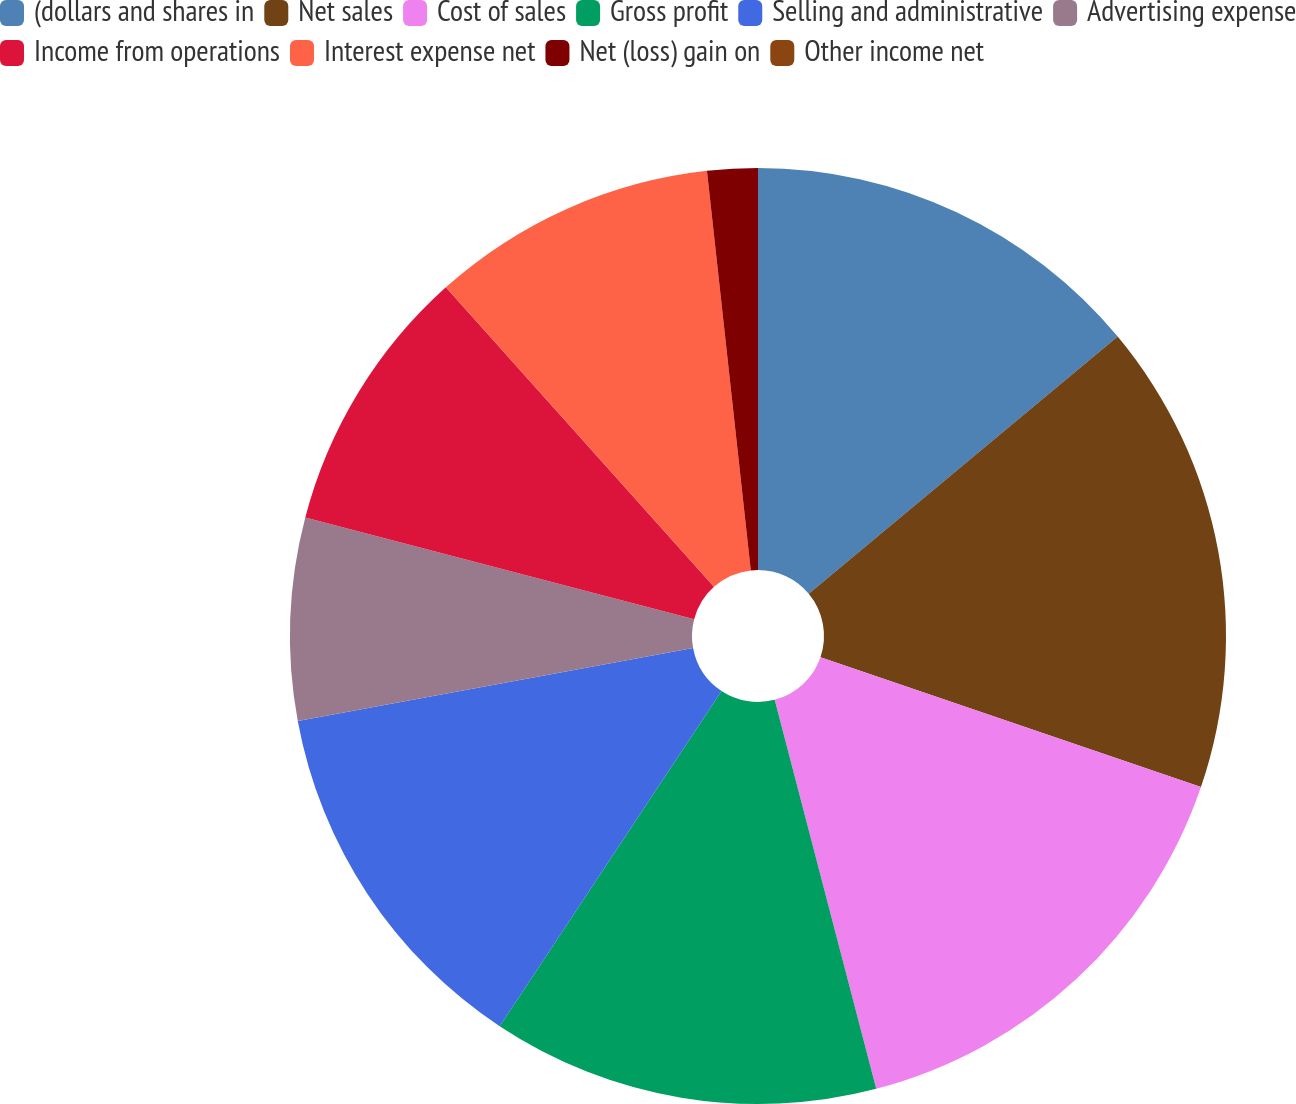<chart> <loc_0><loc_0><loc_500><loc_500><pie_chart><fcel>(dollars and shares in<fcel>Net sales<fcel>Cost of sales<fcel>Gross profit<fcel>Selling and administrative<fcel>Advertising expense<fcel>Income from operations<fcel>Interest expense net<fcel>Net (loss) gain on<fcel>Other income net<nl><fcel>13.95%<fcel>16.28%<fcel>15.7%<fcel>13.37%<fcel>12.79%<fcel>6.98%<fcel>9.3%<fcel>9.88%<fcel>1.74%<fcel>0.0%<nl></chart> 